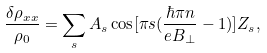Convert formula to latex. <formula><loc_0><loc_0><loc_500><loc_500>\frac { \delta \rho _ { x x } } { \rho _ { 0 } } = \sum _ { s } A _ { s } \cos [ \pi s ( \frac { \hbar { \pi } n } { e B _ { \perp } } - 1 ) ] Z _ { s } ,</formula> 